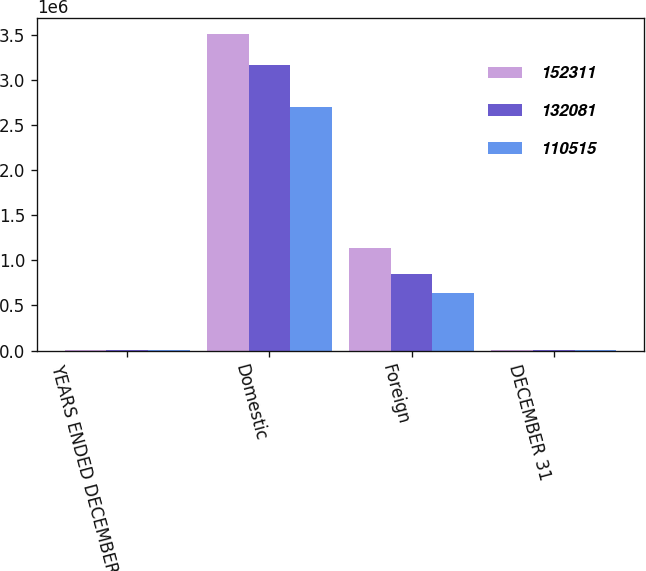Convert chart to OTSL. <chart><loc_0><loc_0><loc_500><loc_500><stacked_bar_chart><ecel><fcel>YEARS ENDED DECEMBER 31<fcel>Domestic<fcel>Foreign<fcel>DECEMBER 31<nl><fcel>152311<fcel>2007<fcel>3.5093e+06<fcel>1.13637e+06<fcel>2007<nl><fcel>132081<fcel>2006<fcel>3.16951e+06<fcel>844037<fcel>2006<nl><fcel>110515<fcel>2005<fcel>2.70239e+06<fcel>636052<fcel>2005<nl></chart> 